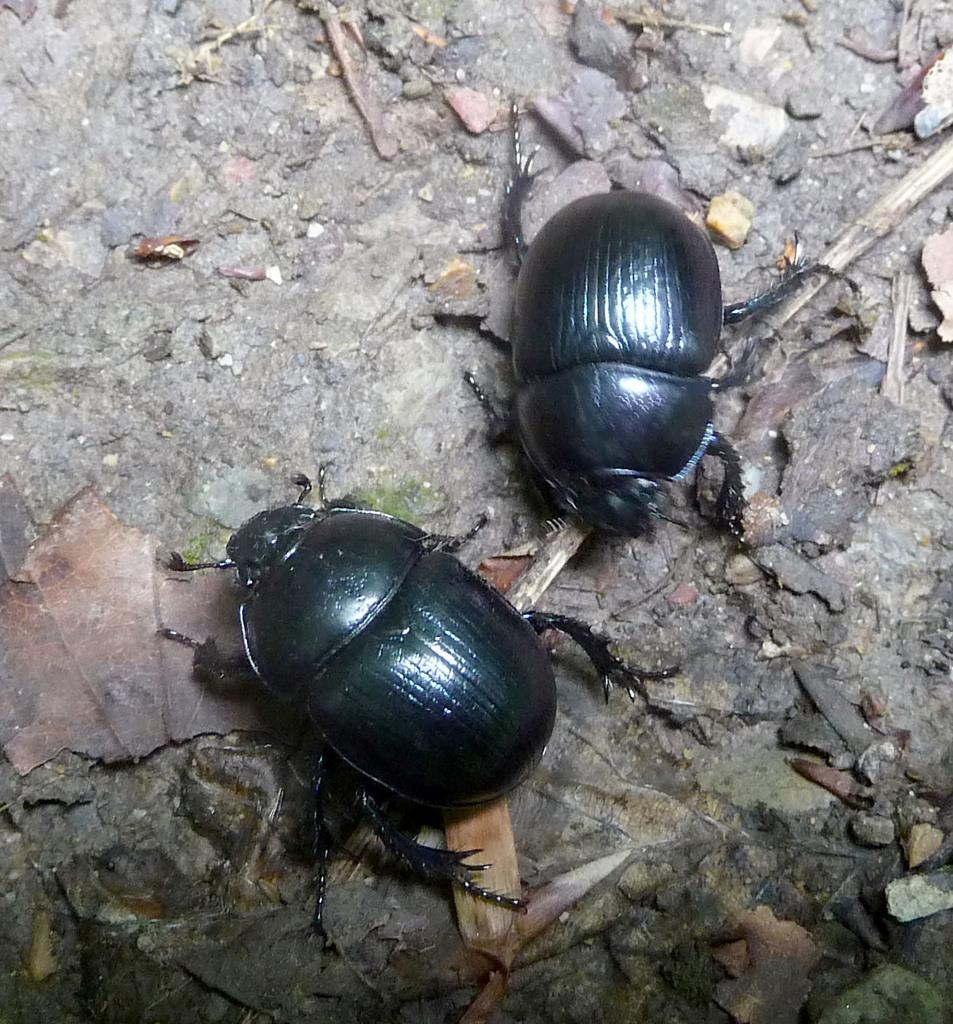What type of creatures can be seen on the ground in the image? There are two insects on the ground in the image. What else can be found on the ground besides the insects? There are dried leaves and an object that looks like a stick on the ground. Are there any other objects present on the ground? Yes, there are other objects on the ground. What type of bed can be seen in the image? There is no bed present in the image; it features insects, dried leaves, and other objects on the ground. What type of lock is used to secure the stew in the image? There is no stew or lock present in the image. 